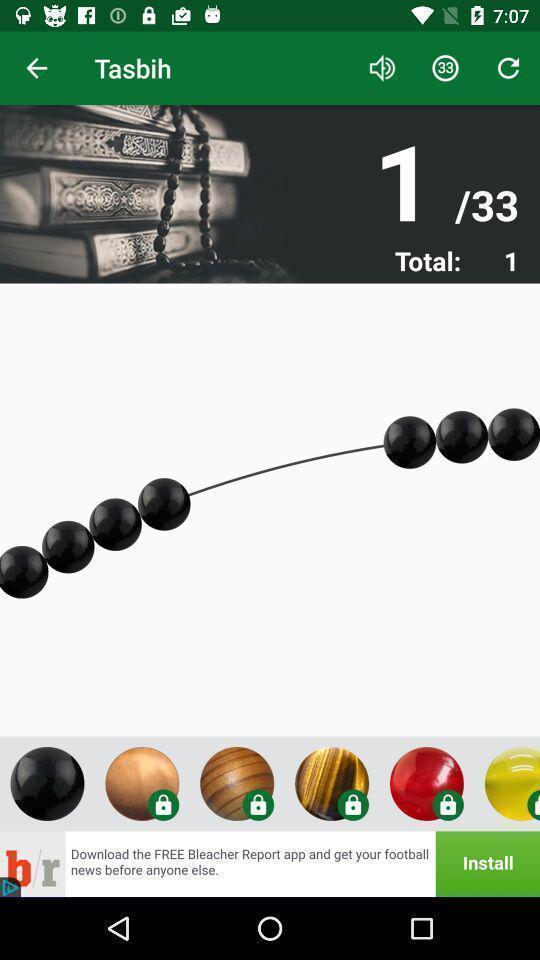Explain the elements present in this screenshot. Screen displaying multiple control options. 